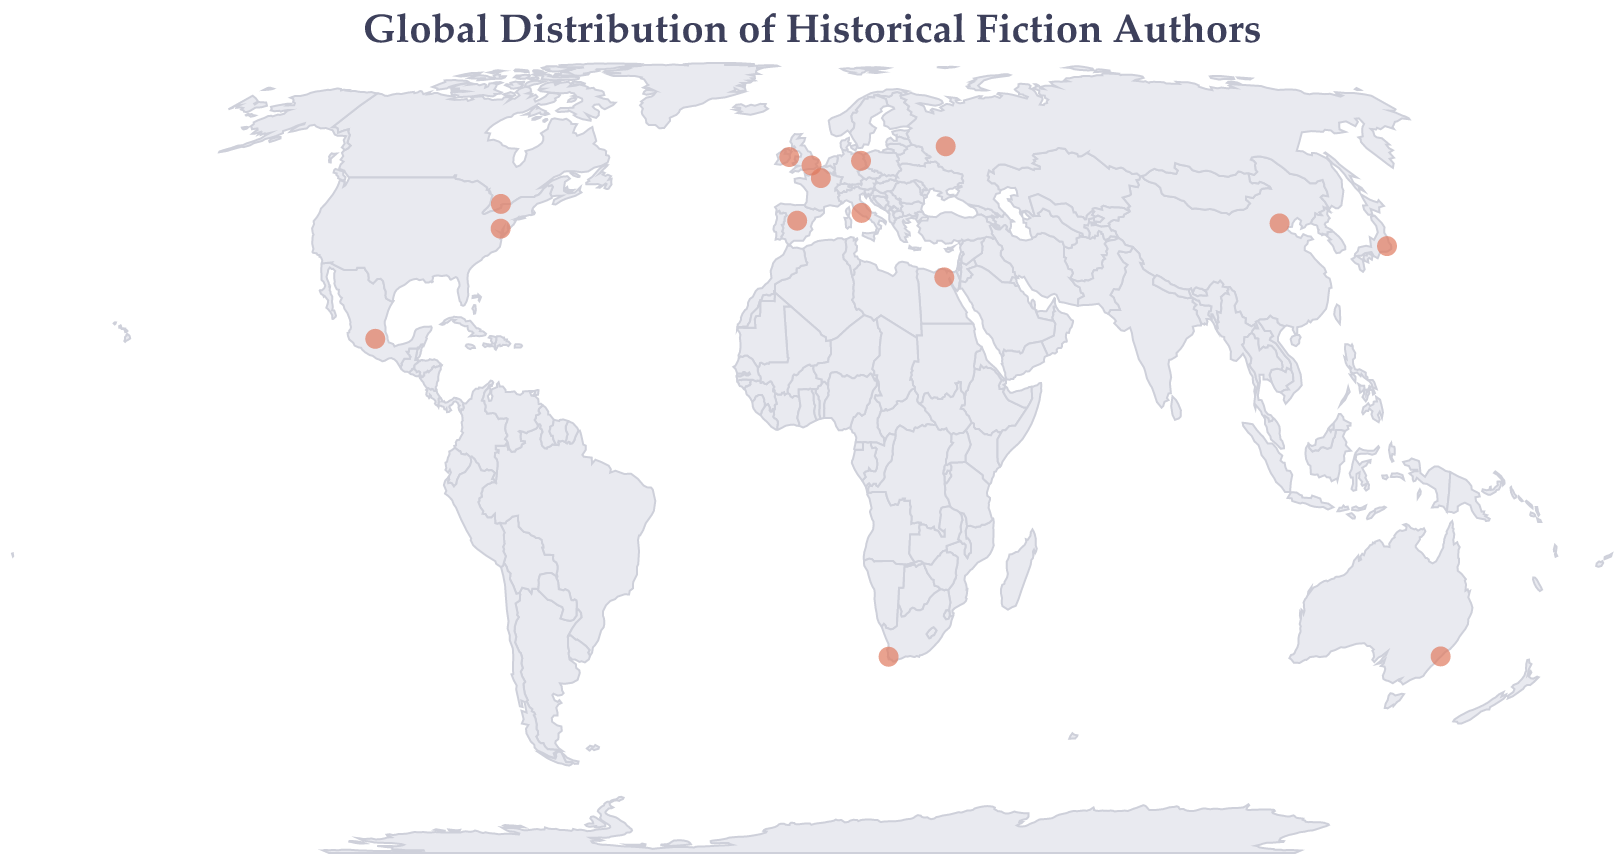How many authors from the plot are from Europe? To find the number of authors from Europe, locate the European countries on the map (United Kingdom, Russia, Spain, France, Italy, Germany, and Ireland) and count the authors associated with each country.
Answer: 7 What historical period is associated with the author from Egypt? Find the tooltip data for Egypt on the map, which will indicate the primary historical period of Naguib Mahfouz.
Answer: Ancient Egypt Which country has an author focusing on the American Civil War? Locate the tooltip information on the map for the country that lists the American Civil War as the primary historical period, which pertains to Geraldine Brooks from the USA.
Answer: USA What is the primary historical period associated with Margaret Atwood? Locate the tooltip information for Margaret Atwood on the map and identify the primary historical period listed.
Answer: 17th Century New England Which region/country has an author interested in the Mexican Revolution? Locate the tooltip mentioning the Mexican Revolution on the map, which would correspond to Laura Esquivel from Mexico.
Answer: Mexico How many authors are primarily interested in the 19th century? Count the number of authors with 19th-century periods, identifying Boris Akunin (19th Century Russia), Sebastian Barry (19th Century Ireland), and Zakes Mda (19th Century South Africa) on the map.
Answer: 3 Compare the historical periods of authors from Japan and China. Which one focuses on an older historical period? Locate the authors from Japan and China on the map, noting Shusaku Endo focuses on the 16th century and Mo Yan on the 20th century. Since the 16th century is older than the 20th century, Shusaku Endo focuses on an older historical period.
Answer: Japan (16th Century) What is the title of the plot? The title is usually displayed prominently at the top of the plot. Read the title text to get the information.
Answer: Global Distribution of Historical Fiction Authors Which author and historical period are associated with France? Locate the tooltip information for France on the map. It will show Marguerite Yourcenar, who is associated with Ancient Rome.
Answer: Marguerite Yourcenar, Ancient Rome Identify any authors who focus on Ancient historical periods. How many are there and who are they? Look for authors with historical periods classified as 'Ancient,' specifically noting Naguib Mahfouz (Ancient Egypt) and Marguerite Yourcenar (Ancient Rome). Count these authors.
Answer: 2; Naguib Mahfouz and Marguerite Yourcenar 